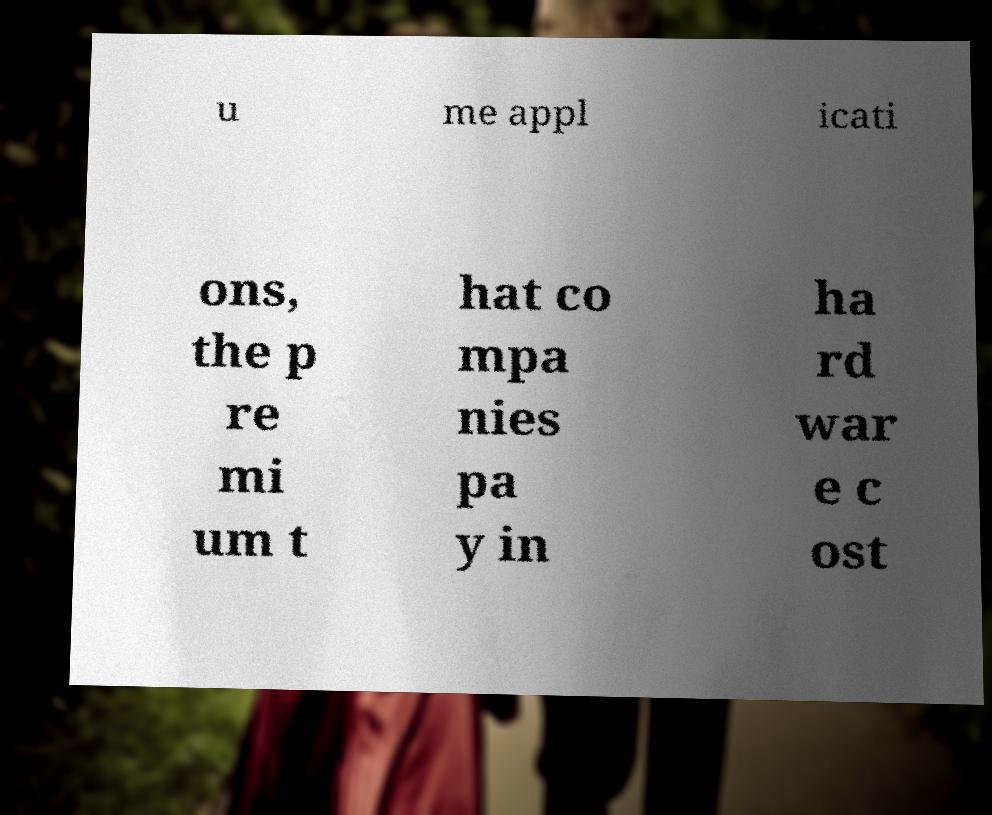There's text embedded in this image that I need extracted. Can you transcribe it verbatim? u me appl icati ons, the p re mi um t hat co mpa nies pa y in ha rd war e c ost 